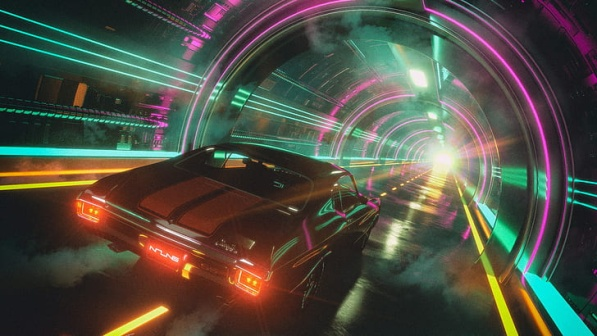What could be waiting at the end of the tunnel? The bright light at the end of the tunnel could symbolize many things. It could represent the car reaching its destination, which could be a futuristic city or a gateway to another realm. Given the advanced and neon-lit aesthetics of the tunnel, it's possible that a highly technological and vibrant urban environment might be awaiting the car. Alternatively, the light could symbolize hope, progress, or the beginning of a new journey, suggesting that whatever lies beyond the tunnel is crucial to the narrative or concept of the image. Imagine if this scene were part of a sci-fi movie. How would the story unfold? In a sci-fi movie, this scene could be pivotal. The story might revolve around the car’s journey to a high-tech city, hidden from the rest of the world. The car could be driven by the protagonist, who is on a mission to deliver crucial information or a groundbreaking invention. The tunnel could serve as both a physical and metaphorical passage, transitioning from an old way of life to a technologically advanced future. Along the way, the protagonist could encounter various challenges, such as technological barriers or adversaries intent on stopping them. The bright light at the end of the tunnel symbolizes hope and progress, indicating that the protagonist is nearing their goal, where they will face the final challenge or revelation. 